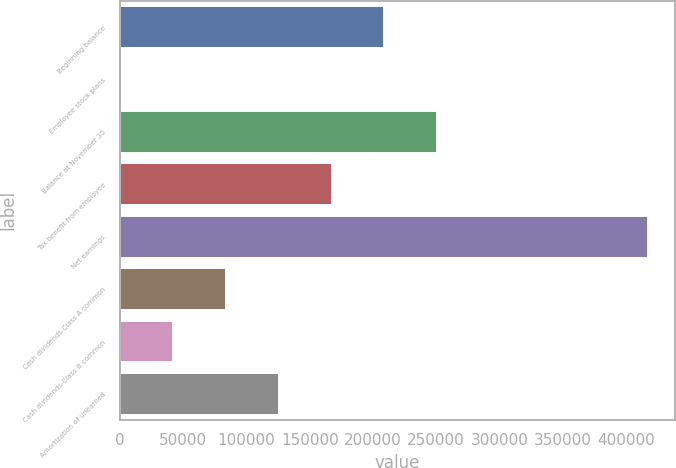Convert chart. <chart><loc_0><loc_0><loc_500><loc_500><bar_chart><fcel>Beginning balance<fcel>Employee stock plans<fcel>Balance at November 30<fcel>Tax benefit from employee<fcel>Net earnings<fcel>Cash dividends-Class A common<fcel>Cash dividends-Class B common<fcel>Amortization of unearned<nl><fcel>209050<fcel>256<fcel>250809<fcel>167292<fcel>417845<fcel>83773.8<fcel>42014.9<fcel>125533<nl></chart> 